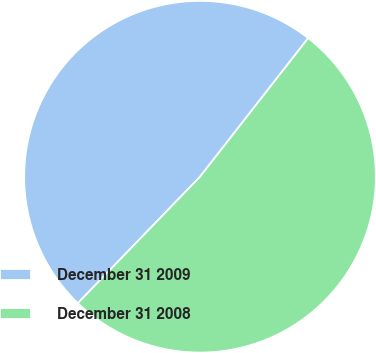Convert chart. <chart><loc_0><loc_0><loc_500><loc_500><pie_chart><fcel>December 31 2009<fcel>December 31 2008<nl><fcel>48.32%<fcel>51.68%<nl></chart> 